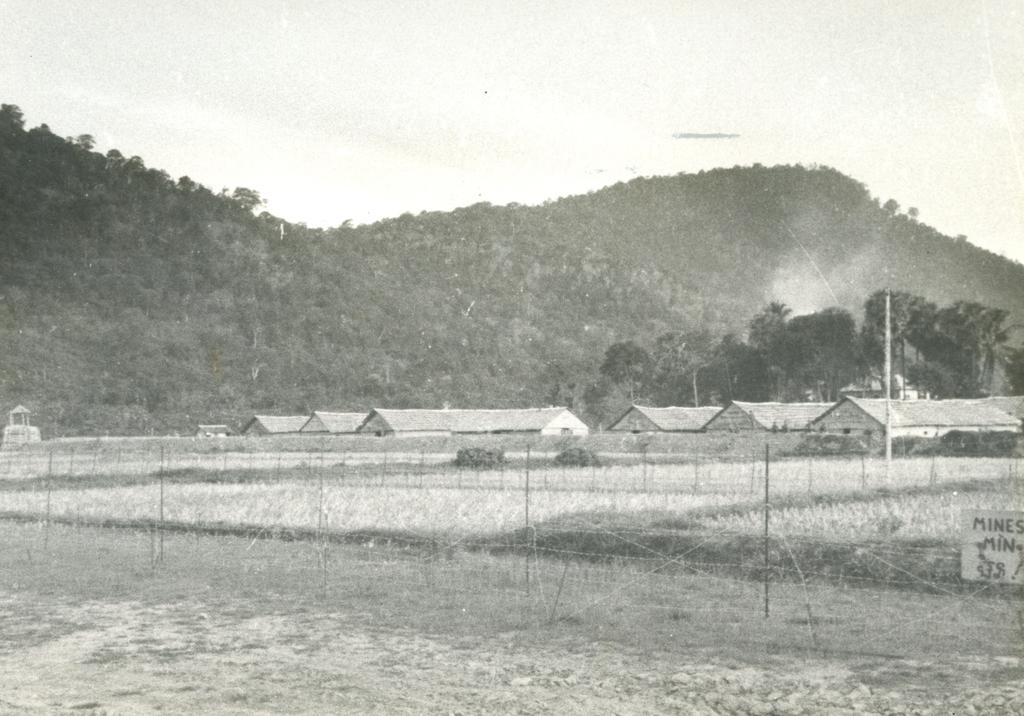What type of natural formation can be seen in the image? There are mountains in the image. What type of vegetation is present in the image? There are trees in the image. What type of human-made structures can be seen in the image? There are houses in the image. What is located in the center of the image? There is a fencing in the center of the image. What can be found in the right bottom corner of the image? There is a sign board in the right bottom corner of the image. What is visible at the top of the image? The sky is visible at the top of the image. What type of print can be seen on the trees in the image? There is no print visible on the trees in the image. What type of authority is depicted in the image? There is no authority figure or symbol present in the image. What emotion can be seen on the faces of the mountains in the image? The mountains do not have faces or emotions; they are inanimate objects. 